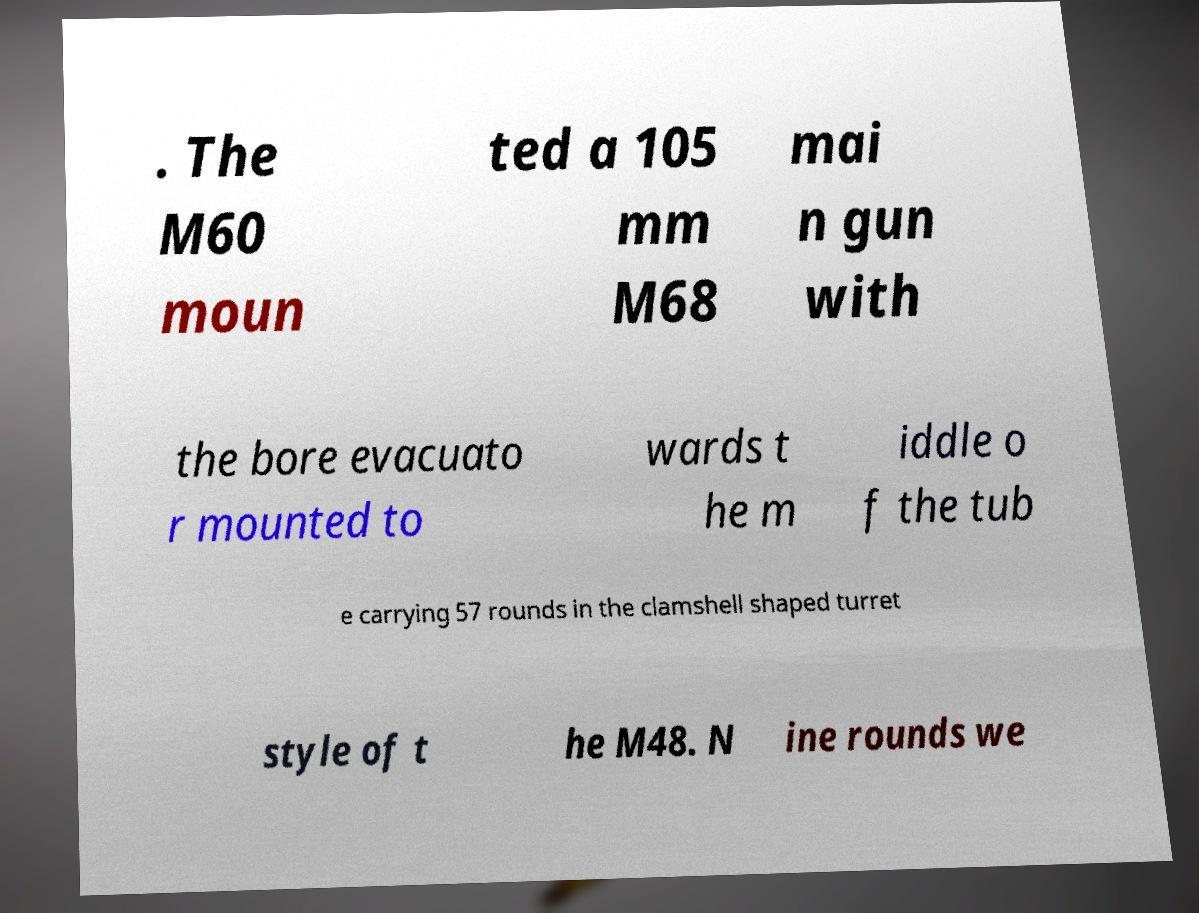There's text embedded in this image that I need extracted. Can you transcribe it verbatim? . The M60 moun ted a 105 mm M68 mai n gun with the bore evacuato r mounted to wards t he m iddle o f the tub e carrying 57 rounds in the clamshell shaped turret style of t he M48. N ine rounds we 